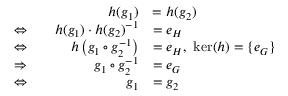<formula> <loc_0><loc_0><loc_500><loc_500>{ \begin{array} { r l r l } & { h ( g _ { 1 } ) } & { = h ( g _ { 2 } ) } \\ { \Leftrightarrow } & { h ( g _ { 1 } ) \cdot h ( g _ { 2 } ) ^ { - 1 } } & { = e _ { H } } \\ { \Leftrightarrow } & { h \left ( g _ { 1 } \circ g _ { 2 } ^ { - 1 } \right ) } & { = e _ { H } , \ \ker ( h ) = \{ e _ { G } \} } \\ { \Rightarrow } & { g _ { 1 } \circ g _ { 2 } ^ { - 1 } } & { = e _ { G } } \\ { \Leftrightarrow } & { g _ { 1 } } & { = g _ { 2 } } \end{array} }</formula> 